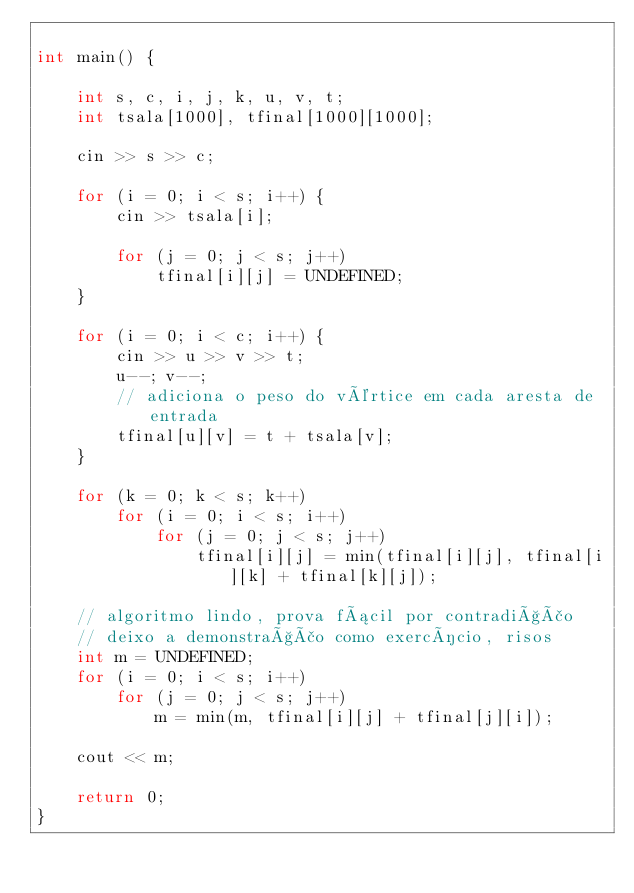<code> <loc_0><loc_0><loc_500><loc_500><_C++_>
int main() {

    int s, c, i, j, k, u, v, t;
    int tsala[1000], tfinal[1000][1000];
    
    cin >> s >> c;
    
    for (i = 0; i < s; i++) {
        cin >> tsala[i];
        
        for (j = 0; j < s; j++)
            tfinal[i][j] = UNDEFINED;
    }  
    
    for (i = 0; i < c; i++) {
        cin >> u >> v >> t;
        u--; v--;
        // adiciona o peso do vértice em cada aresta de entrada
        tfinal[u][v] = t + tsala[v];
    }
    
    for (k = 0; k < s; k++)
        for (i = 0; i < s; i++)
            for (j = 0; j < s; j++)
                tfinal[i][j] = min(tfinal[i][j], tfinal[i][k] + tfinal[k][j]);
                
    // algoritmo lindo, prova fácil por contradição
    // deixo a demonstração como exercício, risos
    int m = UNDEFINED;
    for (i = 0; i < s; i++)
        for (j = 0; j < s; j++)
            m = min(m, tfinal[i][j] + tfinal[j][i]);
               
    cout << m;

    return 0;
}
</code> 